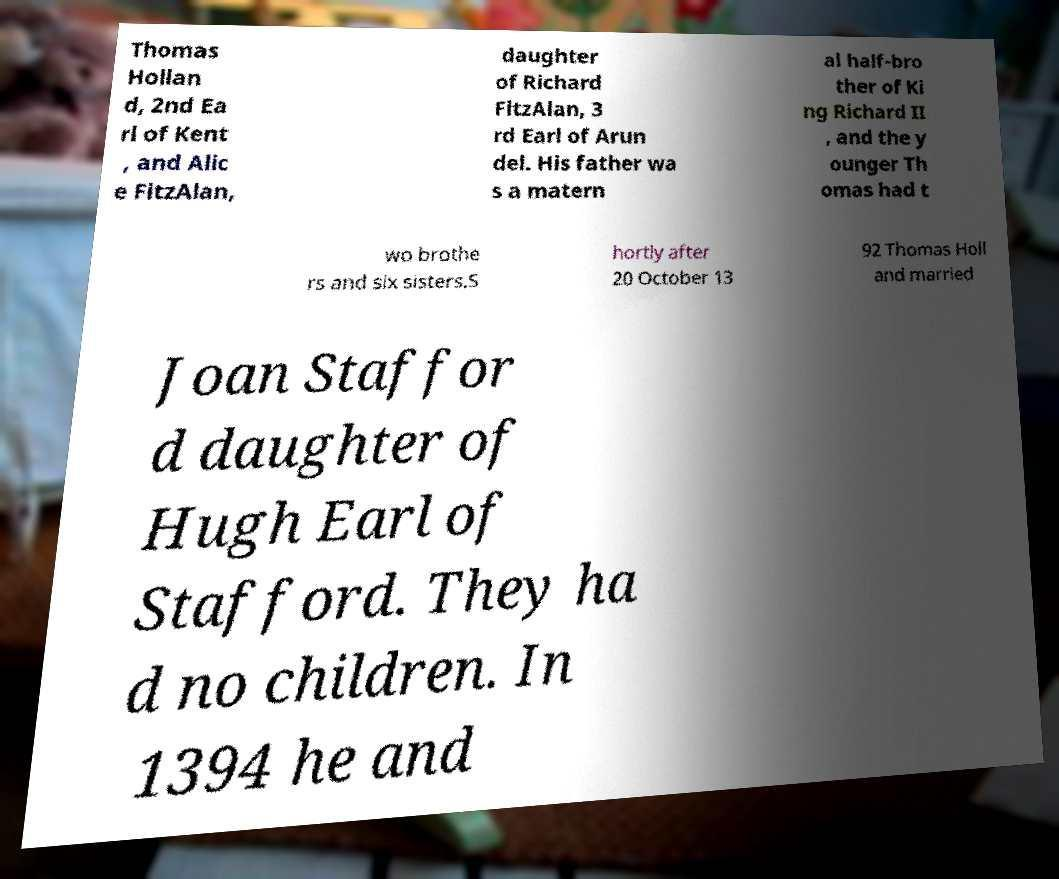I need the written content from this picture converted into text. Can you do that? Thomas Hollan d, 2nd Ea rl of Kent , and Alic e FitzAlan, daughter of Richard FitzAlan, 3 rd Earl of Arun del. His father wa s a matern al half-bro ther of Ki ng Richard II , and the y ounger Th omas had t wo brothe rs and six sisters.S hortly after 20 October 13 92 Thomas Holl and married Joan Staffor d daughter of Hugh Earl of Stafford. They ha d no children. In 1394 he and 